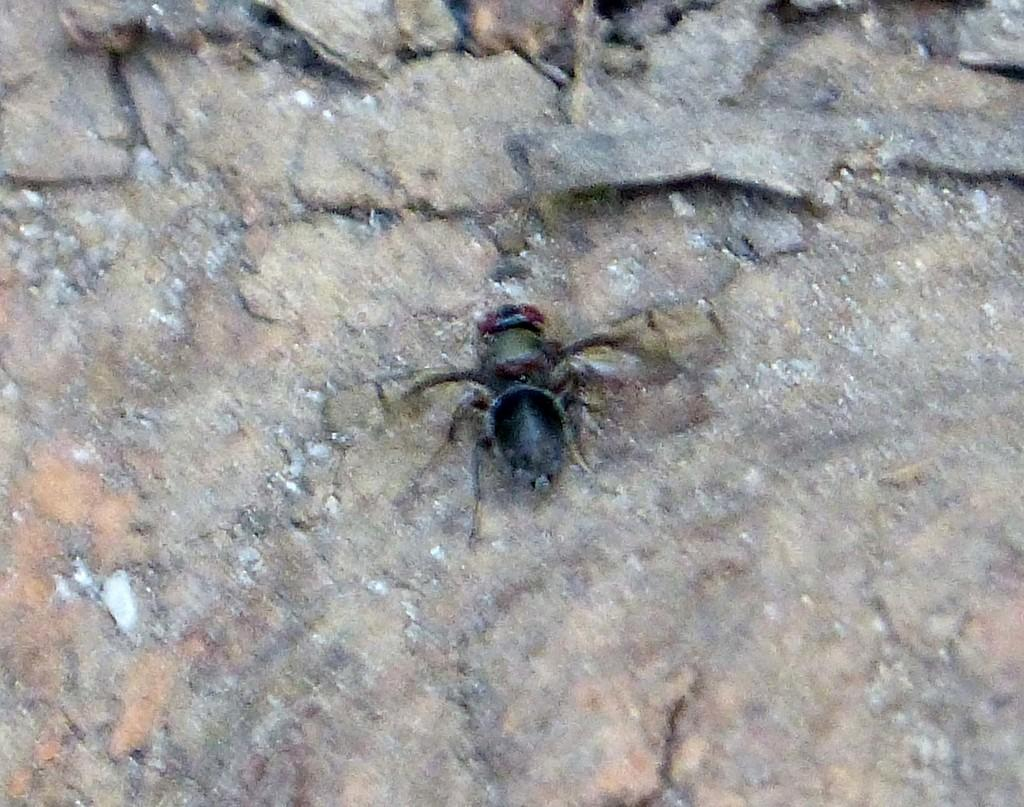What type of creature can be seen in the image? There is an insect in the image. What type of powder is being used to measure the kitty's weight in the image? There is no powder or kitty present in the image; it only features an insect. 